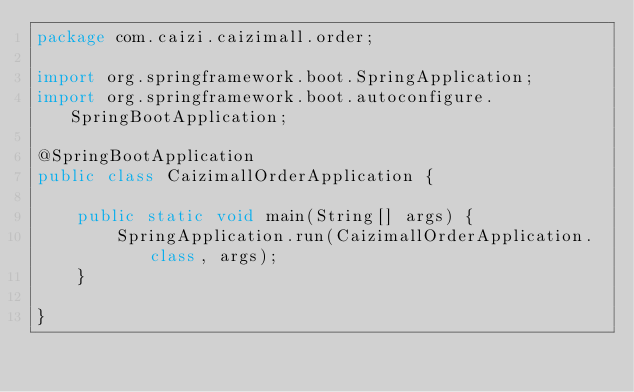<code> <loc_0><loc_0><loc_500><loc_500><_Java_>package com.caizi.caizimall.order;

import org.springframework.boot.SpringApplication;
import org.springframework.boot.autoconfigure.SpringBootApplication;

@SpringBootApplication
public class CaizimallOrderApplication {

    public static void main(String[] args) {
        SpringApplication.run(CaizimallOrderApplication.class, args);
    }

}
</code> 